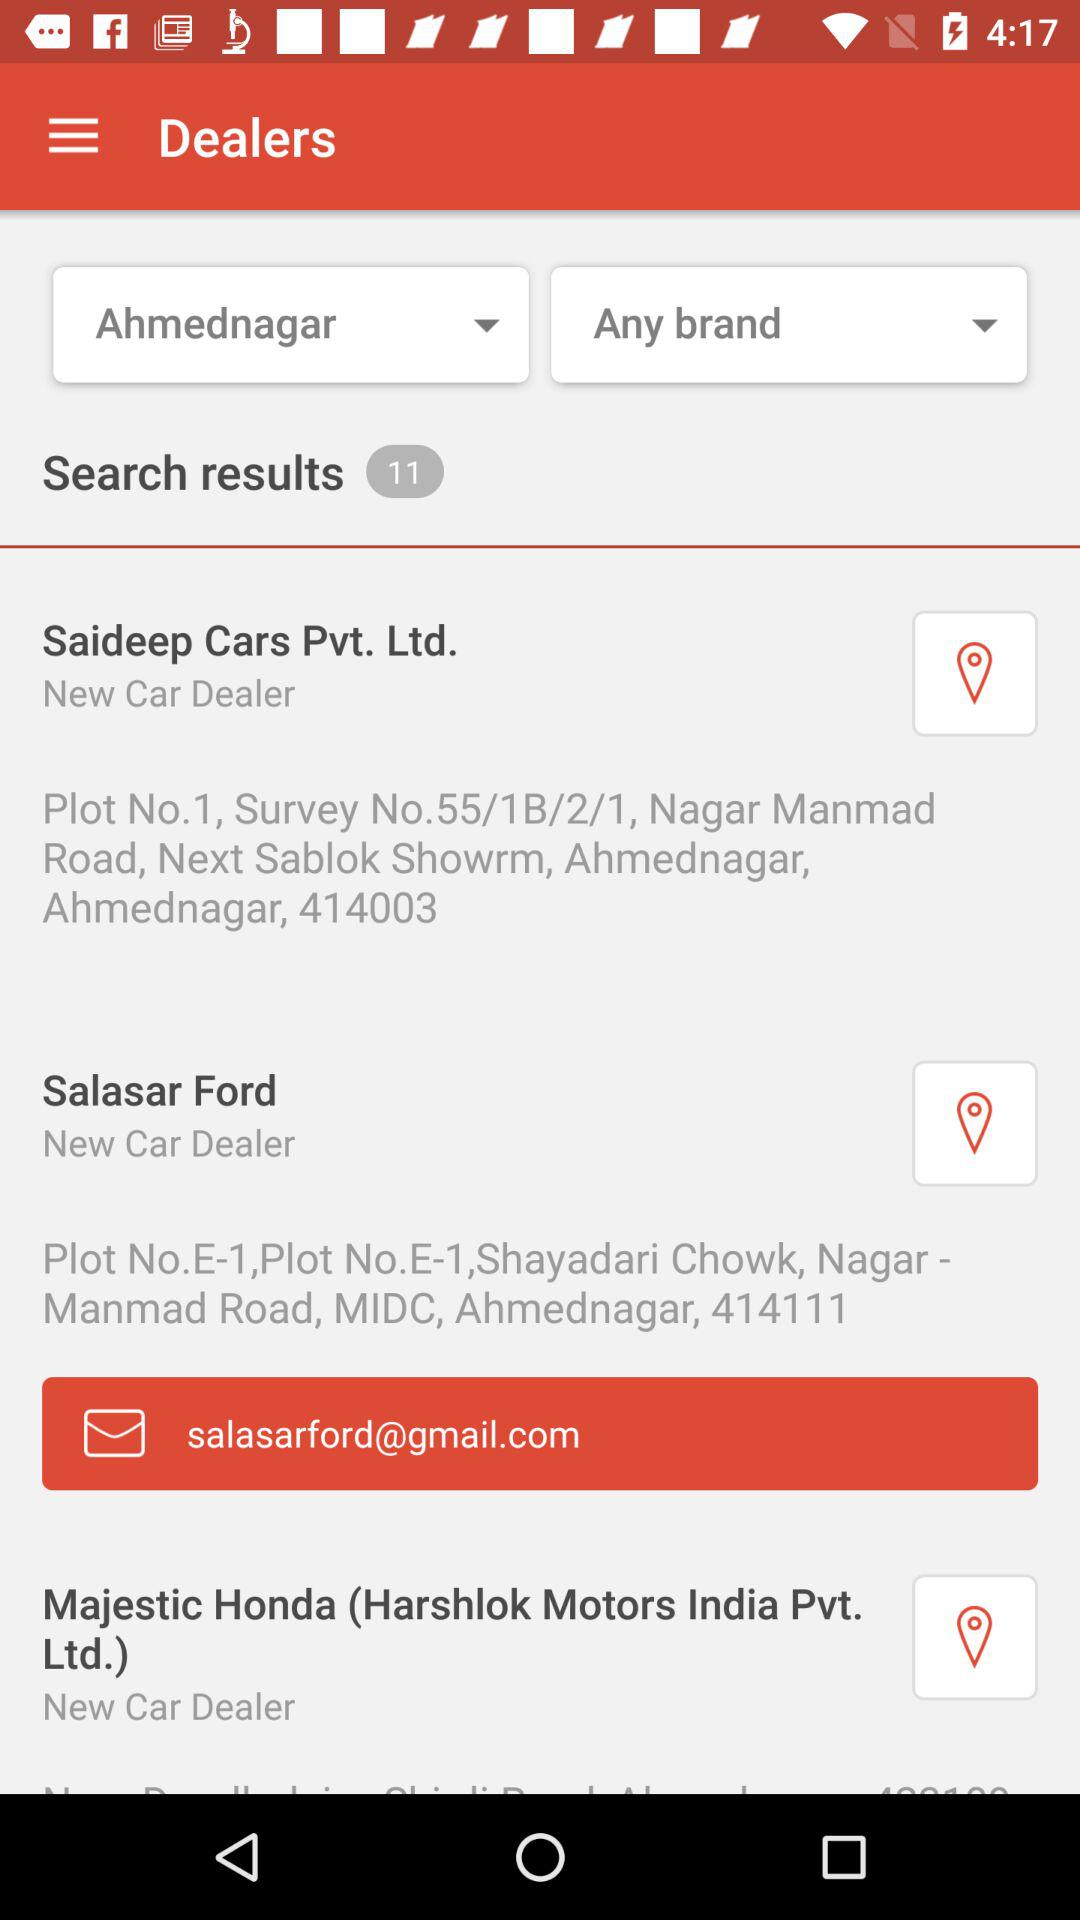Which location is selected? The selected location is Ahmednagar. 